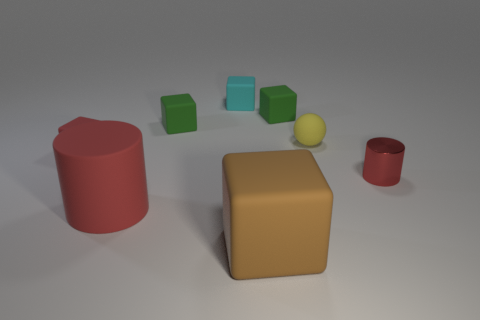How many small red things have the same material as the large red cylinder?
Your answer should be very brief. 1. There is a tiny metal thing that is the same color as the rubber cylinder; what is its shape?
Give a very brief answer. Cylinder. Are there any other brown objects that have the same shape as the brown rubber object?
Keep it short and to the point. No. What shape is the yellow matte thing that is the same size as the cyan matte thing?
Provide a succinct answer. Sphere. There is a rubber cylinder; does it have the same color as the small rubber thing that is in front of the yellow sphere?
Make the answer very short. Yes. There is a tiny matte cube in front of the matte ball; how many tiny yellow matte balls are left of it?
Provide a succinct answer. 0. What is the size of the block that is both right of the small cyan rubber cube and behind the brown rubber block?
Offer a terse response. Small. Are there any green shiny cylinders of the same size as the matte cylinder?
Offer a terse response. No. Are there more red blocks on the right side of the metallic object than tiny cyan rubber things that are on the right side of the brown thing?
Ensure brevity in your answer.  No. Are the tiny yellow thing and the green thing to the right of the brown object made of the same material?
Your answer should be very brief. Yes. 